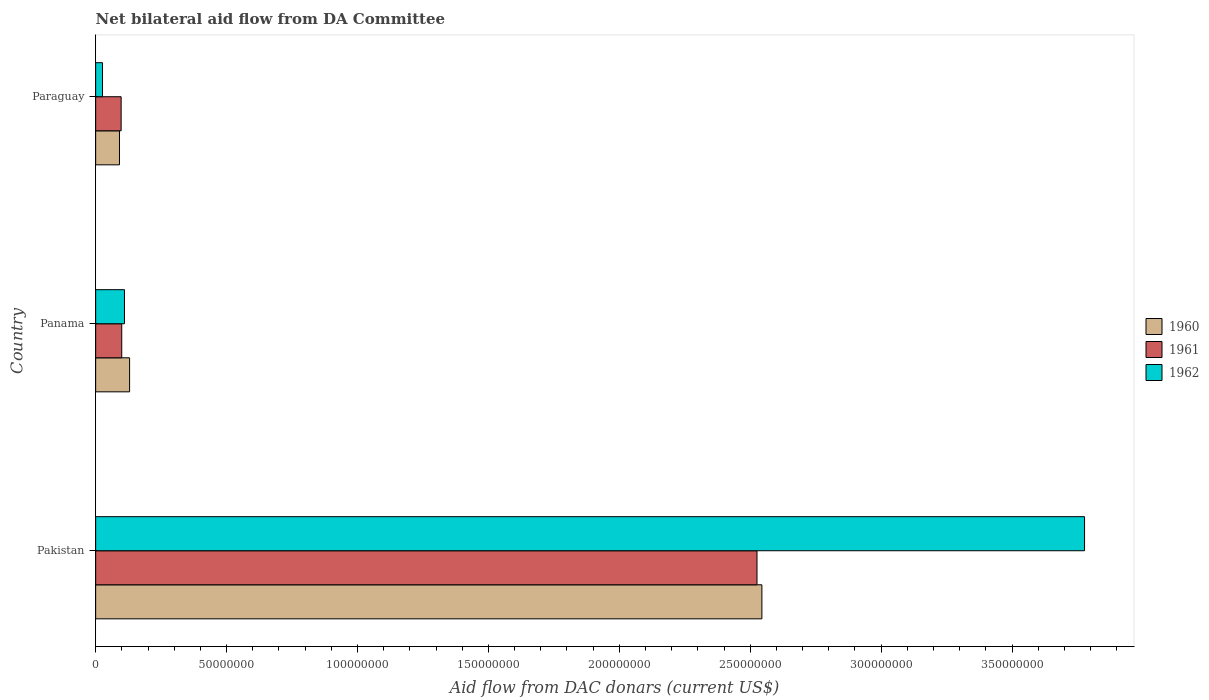How many groups of bars are there?
Provide a succinct answer. 3. Are the number of bars per tick equal to the number of legend labels?
Give a very brief answer. Yes. How many bars are there on the 3rd tick from the top?
Your answer should be compact. 3. What is the label of the 1st group of bars from the top?
Offer a terse response. Paraguay. What is the aid flow in in 1961 in Pakistan?
Ensure brevity in your answer.  2.53e+08. Across all countries, what is the maximum aid flow in in 1962?
Your response must be concise. 3.78e+08. Across all countries, what is the minimum aid flow in in 1961?
Offer a terse response. 9.73e+06. In which country was the aid flow in in 1962 minimum?
Your response must be concise. Paraguay. What is the total aid flow in in 1961 in the graph?
Offer a very short reply. 2.72e+08. What is the difference between the aid flow in in 1962 in Pakistan and that in Paraguay?
Your response must be concise. 3.75e+08. What is the difference between the aid flow in in 1960 in Panama and the aid flow in in 1961 in Pakistan?
Your answer should be very brief. -2.40e+08. What is the average aid flow in in 1962 per country?
Provide a succinct answer. 1.30e+08. What is the difference between the aid flow in in 1961 and aid flow in in 1960 in Pakistan?
Offer a very short reply. -1.87e+06. What is the ratio of the aid flow in in 1962 in Pakistan to that in Panama?
Your answer should be compact. 34.31. Is the difference between the aid flow in in 1961 in Pakistan and Paraguay greater than the difference between the aid flow in in 1960 in Pakistan and Paraguay?
Make the answer very short. No. What is the difference between the highest and the second highest aid flow in in 1962?
Give a very brief answer. 3.67e+08. What is the difference between the highest and the lowest aid flow in in 1960?
Your answer should be very brief. 2.45e+08. In how many countries, is the aid flow in in 1962 greater than the average aid flow in in 1962 taken over all countries?
Provide a succinct answer. 1. Is the sum of the aid flow in in 1962 in Pakistan and Panama greater than the maximum aid flow in in 1960 across all countries?
Make the answer very short. Yes. What does the 3rd bar from the top in Paraguay represents?
Make the answer very short. 1960. Are all the bars in the graph horizontal?
Provide a succinct answer. Yes. What is the difference between two consecutive major ticks on the X-axis?
Offer a terse response. 5.00e+07. Are the values on the major ticks of X-axis written in scientific E-notation?
Your answer should be very brief. No. Does the graph contain any zero values?
Keep it short and to the point. No. Where does the legend appear in the graph?
Make the answer very short. Center right. How are the legend labels stacked?
Offer a very short reply. Vertical. What is the title of the graph?
Your answer should be very brief. Net bilateral aid flow from DA Committee. Does "1987" appear as one of the legend labels in the graph?
Give a very brief answer. No. What is the label or title of the X-axis?
Your answer should be very brief. Aid flow from DAC donars (current US$). What is the Aid flow from DAC donars (current US$) of 1960 in Pakistan?
Ensure brevity in your answer.  2.54e+08. What is the Aid flow from DAC donars (current US$) of 1961 in Pakistan?
Your response must be concise. 2.53e+08. What is the Aid flow from DAC donars (current US$) of 1962 in Pakistan?
Your answer should be very brief. 3.78e+08. What is the Aid flow from DAC donars (current US$) in 1960 in Panama?
Keep it short and to the point. 1.30e+07. What is the Aid flow from DAC donars (current US$) in 1961 in Panama?
Your response must be concise. 9.96e+06. What is the Aid flow from DAC donars (current US$) of 1962 in Panama?
Provide a short and direct response. 1.10e+07. What is the Aid flow from DAC donars (current US$) in 1960 in Paraguay?
Give a very brief answer. 9.10e+06. What is the Aid flow from DAC donars (current US$) of 1961 in Paraguay?
Your answer should be very brief. 9.73e+06. What is the Aid flow from DAC donars (current US$) of 1962 in Paraguay?
Give a very brief answer. 2.62e+06. Across all countries, what is the maximum Aid flow from DAC donars (current US$) of 1960?
Provide a short and direct response. 2.54e+08. Across all countries, what is the maximum Aid flow from DAC donars (current US$) of 1961?
Offer a terse response. 2.53e+08. Across all countries, what is the maximum Aid flow from DAC donars (current US$) in 1962?
Keep it short and to the point. 3.78e+08. Across all countries, what is the minimum Aid flow from DAC donars (current US$) of 1960?
Provide a succinct answer. 9.10e+06. Across all countries, what is the minimum Aid flow from DAC donars (current US$) in 1961?
Offer a very short reply. 9.73e+06. Across all countries, what is the minimum Aid flow from DAC donars (current US$) in 1962?
Give a very brief answer. 2.62e+06. What is the total Aid flow from DAC donars (current US$) of 1960 in the graph?
Your answer should be very brief. 2.77e+08. What is the total Aid flow from DAC donars (current US$) in 1961 in the graph?
Your answer should be compact. 2.72e+08. What is the total Aid flow from DAC donars (current US$) in 1962 in the graph?
Make the answer very short. 3.91e+08. What is the difference between the Aid flow from DAC donars (current US$) of 1960 in Pakistan and that in Panama?
Give a very brief answer. 2.42e+08. What is the difference between the Aid flow from DAC donars (current US$) in 1961 in Pakistan and that in Panama?
Offer a terse response. 2.43e+08. What is the difference between the Aid flow from DAC donars (current US$) of 1962 in Pakistan and that in Panama?
Ensure brevity in your answer.  3.67e+08. What is the difference between the Aid flow from DAC donars (current US$) in 1960 in Pakistan and that in Paraguay?
Your answer should be very brief. 2.45e+08. What is the difference between the Aid flow from DAC donars (current US$) in 1961 in Pakistan and that in Paraguay?
Your answer should be compact. 2.43e+08. What is the difference between the Aid flow from DAC donars (current US$) of 1962 in Pakistan and that in Paraguay?
Offer a terse response. 3.75e+08. What is the difference between the Aid flow from DAC donars (current US$) in 1960 in Panama and that in Paraguay?
Your answer should be compact. 3.86e+06. What is the difference between the Aid flow from DAC donars (current US$) in 1962 in Panama and that in Paraguay?
Your response must be concise. 8.39e+06. What is the difference between the Aid flow from DAC donars (current US$) of 1960 in Pakistan and the Aid flow from DAC donars (current US$) of 1961 in Panama?
Offer a terse response. 2.45e+08. What is the difference between the Aid flow from DAC donars (current US$) of 1960 in Pakistan and the Aid flow from DAC donars (current US$) of 1962 in Panama?
Offer a terse response. 2.43e+08. What is the difference between the Aid flow from DAC donars (current US$) of 1961 in Pakistan and the Aid flow from DAC donars (current US$) of 1962 in Panama?
Make the answer very short. 2.42e+08. What is the difference between the Aid flow from DAC donars (current US$) in 1960 in Pakistan and the Aid flow from DAC donars (current US$) in 1961 in Paraguay?
Provide a succinct answer. 2.45e+08. What is the difference between the Aid flow from DAC donars (current US$) in 1960 in Pakistan and the Aid flow from DAC donars (current US$) in 1962 in Paraguay?
Provide a succinct answer. 2.52e+08. What is the difference between the Aid flow from DAC donars (current US$) of 1961 in Pakistan and the Aid flow from DAC donars (current US$) of 1962 in Paraguay?
Give a very brief answer. 2.50e+08. What is the difference between the Aid flow from DAC donars (current US$) in 1960 in Panama and the Aid flow from DAC donars (current US$) in 1961 in Paraguay?
Offer a very short reply. 3.23e+06. What is the difference between the Aid flow from DAC donars (current US$) in 1960 in Panama and the Aid flow from DAC donars (current US$) in 1962 in Paraguay?
Provide a succinct answer. 1.03e+07. What is the difference between the Aid flow from DAC donars (current US$) in 1961 in Panama and the Aid flow from DAC donars (current US$) in 1962 in Paraguay?
Provide a short and direct response. 7.34e+06. What is the average Aid flow from DAC donars (current US$) in 1960 per country?
Your response must be concise. 9.22e+07. What is the average Aid flow from DAC donars (current US$) of 1961 per country?
Ensure brevity in your answer.  9.08e+07. What is the average Aid flow from DAC donars (current US$) of 1962 per country?
Your response must be concise. 1.30e+08. What is the difference between the Aid flow from DAC donars (current US$) in 1960 and Aid flow from DAC donars (current US$) in 1961 in Pakistan?
Provide a succinct answer. 1.87e+06. What is the difference between the Aid flow from DAC donars (current US$) of 1960 and Aid flow from DAC donars (current US$) of 1962 in Pakistan?
Your answer should be very brief. -1.23e+08. What is the difference between the Aid flow from DAC donars (current US$) in 1961 and Aid flow from DAC donars (current US$) in 1962 in Pakistan?
Your response must be concise. -1.25e+08. What is the difference between the Aid flow from DAC donars (current US$) of 1960 and Aid flow from DAC donars (current US$) of 1962 in Panama?
Offer a terse response. 1.95e+06. What is the difference between the Aid flow from DAC donars (current US$) in 1961 and Aid flow from DAC donars (current US$) in 1962 in Panama?
Make the answer very short. -1.05e+06. What is the difference between the Aid flow from DAC donars (current US$) of 1960 and Aid flow from DAC donars (current US$) of 1961 in Paraguay?
Offer a very short reply. -6.30e+05. What is the difference between the Aid flow from DAC donars (current US$) of 1960 and Aid flow from DAC donars (current US$) of 1962 in Paraguay?
Your response must be concise. 6.48e+06. What is the difference between the Aid flow from DAC donars (current US$) in 1961 and Aid flow from DAC donars (current US$) in 1962 in Paraguay?
Offer a very short reply. 7.11e+06. What is the ratio of the Aid flow from DAC donars (current US$) of 1960 in Pakistan to that in Panama?
Make the answer very short. 19.64. What is the ratio of the Aid flow from DAC donars (current US$) of 1961 in Pakistan to that in Panama?
Offer a terse response. 25.36. What is the ratio of the Aid flow from DAC donars (current US$) of 1962 in Pakistan to that in Panama?
Your response must be concise. 34.31. What is the ratio of the Aid flow from DAC donars (current US$) of 1960 in Pakistan to that in Paraguay?
Ensure brevity in your answer.  27.96. What is the ratio of the Aid flow from DAC donars (current US$) of 1961 in Pakistan to that in Paraguay?
Offer a very short reply. 25.96. What is the ratio of the Aid flow from DAC donars (current US$) in 1962 in Pakistan to that in Paraguay?
Your answer should be very brief. 144.16. What is the ratio of the Aid flow from DAC donars (current US$) in 1960 in Panama to that in Paraguay?
Your answer should be compact. 1.42. What is the ratio of the Aid flow from DAC donars (current US$) in 1961 in Panama to that in Paraguay?
Keep it short and to the point. 1.02. What is the ratio of the Aid flow from DAC donars (current US$) of 1962 in Panama to that in Paraguay?
Your answer should be very brief. 4.2. What is the difference between the highest and the second highest Aid flow from DAC donars (current US$) of 1960?
Make the answer very short. 2.42e+08. What is the difference between the highest and the second highest Aid flow from DAC donars (current US$) in 1961?
Your response must be concise. 2.43e+08. What is the difference between the highest and the second highest Aid flow from DAC donars (current US$) of 1962?
Offer a terse response. 3.67e+08. What is the difference between the highest and the lowest Aid flow from DAC donars (current US$) in 1960?
Ensure brevity in your answer.  2.45e+08. What is the difference between the highest and the lowest Aid flow from DAC donars (current US$) of 1961?
Give a very brief answer. 2.43e+08. What is the difference between the highest and the lowest Aid flow from DAC donars (current US$) of 1962?
Keep it short and to the point. 3.75e+08. 